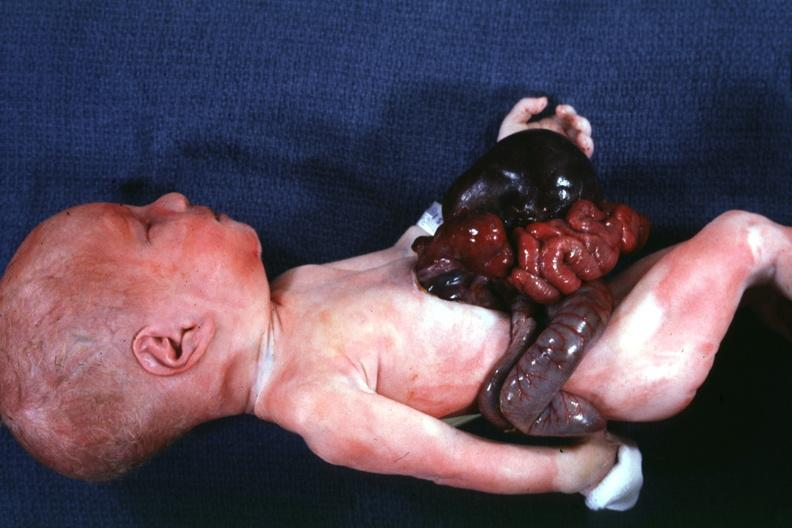where is this area in the body?
Answer the question using a single word or phrase. Abdomen 